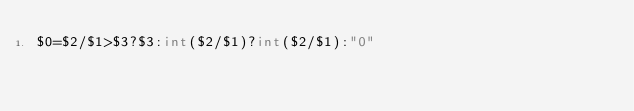<code> <loc_0><loc_0><loc_500><loc_500><_Awk_>$0=$2/$1>$3?$3:int($2/$1)?int($2/$1):"0"</code> 